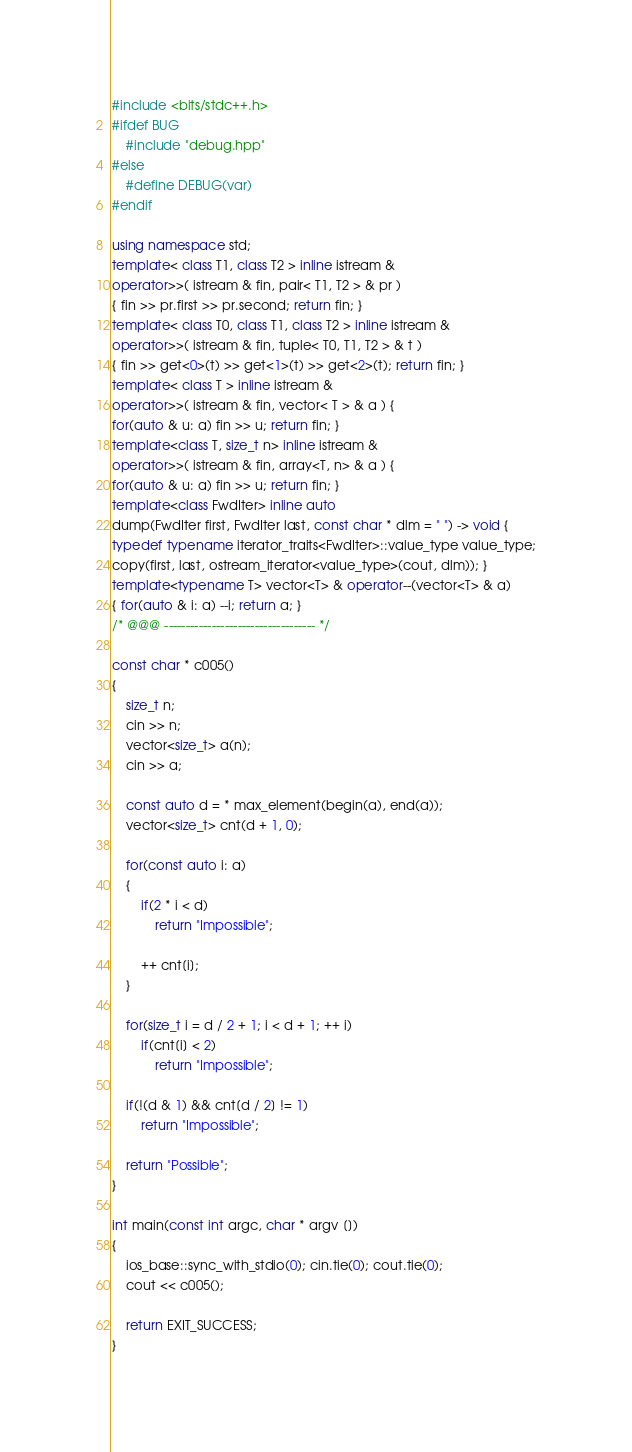Convert code to text. <code><loc_0><loc_0><loc_500><loc_500><_C++_>#include <bits/stdc++.h>
#ifdef BUG
    #include "debug.hpp"
#else
    #define DEBUG(var)
#endif

using namespace std;
template< class T1, class T2 > inline istream &
operator>>( istream & fin, pair< T1, T2 > & pr )
{ fin >> pr.first >> pr.second; return fin; }
template< class T0, class T1, class T2 > inline istream &
operator>>( istream & fin, tuple< T0, T1, T2 > & t )
{ fin >> get<0>(t) >> get<1>(t) >> get<2>(t); return fin; }
template< class T > inline istream &
operator>>( istream & fin, vector< T > & a ) {
for(auto & u: a) fin >> u; return fin; }
template<class T, size_t n> inline istream &
operator>>( istream & fin, array<T, n> & a ) {
for(auto & u: a) fin >> u; return fin; }
template<class FwdIter> inline auto
dump(FwdIter first, FwdIter last, const char * dlm = " ") -> void {
typedef typename iterator_traits<FwdIter>::value_type value_type;
copy(first, last, ostream_iterator<value_type>(cout, dlm)); }
template<typename T> vector<T> & operator--(vector<T> & a)
{ for(auto & i: a) --i; return a; }
/* @@@ ----------------------------------- */

const char * c005()
{
    size_t n;
    cin >> n;
    vector<size_t> a(n);
    cin >> a;

    const auto d = * max_element(begin(a), end(a));
    vector<size_t> cnt(d + 1, 0);

    for(const auto i: a)
    {
        if(2 * i < d)
            return "Impossible";

        ++ cnt[i];
    }

    for(size_t i = d / 2 + 1; i < d + 1; ++ i)
        if(cnt[i] < 2)
            return "Impossible";

    if(!(d & 1) && cnt[d / 2] != 1)
        return "Impossible";

    return "Possible";
}

int main(const int argc, char * argv [])
{
    ios_base::sync_with_stdio(0); cin.tie(0); cout.tie(0);
    cout << c005();

    return EXIT_SUCCESS;
}
</code> 